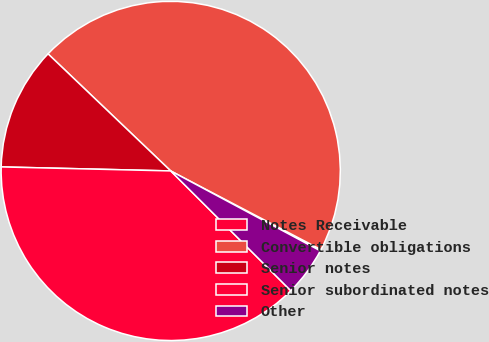Convert chart. <chart><loc_0><loc_0><loc_500><loc_500><pie_chart><fcel>Notes Receivable<fcel>Convertible obligations<fcel>Senior notes<fcel>Senior subordinated notes<fcel>Other<nl><fcel>0.13%<fcel>45.55%<fcel>11.75%<fcel>37.9%<fcel>4.67%<nl></chart> 